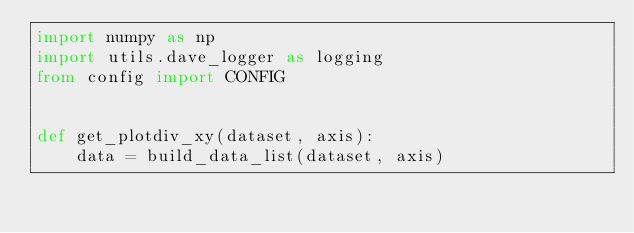<code> <loc_0><loc_0><loc_500><loc_500><_Python_>import numpy as np
import utils.dave_logger as logging
from config import CONFIG


def get_plotdiv_xy(dataset, axis):
    data = build_data_list(dataset, axis)</code> 